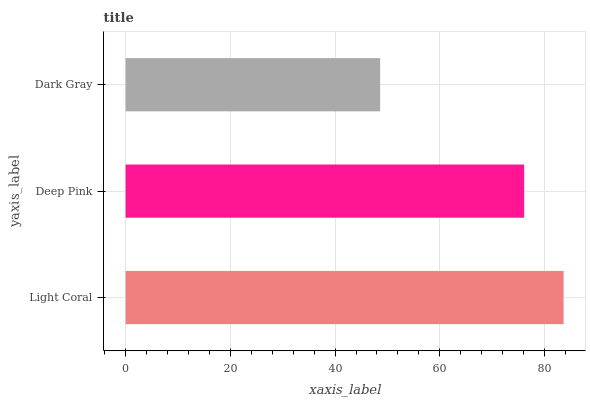Is Dark Gray the minimum?
Answer yes or no. Yes. Is Light Coral the maximum?
Answer yes or no. Yes. Is Deep Pink the minimum?
Answer yes or no. No. Is Deep Pink the maximum?
Answer yes or no. No. Is Light Coral greater than Deep Pink?
Answer yes or no. Yes. Is Deep Pink less than Light Coral?
Answer yes or no. Yes. Is Deep Pink greater than Light Coral?
Answer yes or no. No. Is Light Coral less than Deep Pink?
Answer yes or no. No. Is Deep Pink the high median?
Answer yes or no. Yes. Is Deep Pink the low median?
Answer yes or no. Yes. Is Dark Gray the high median?
Answer yes or no. No. Is Light Coral the low median?
Answer yes or no. No. 